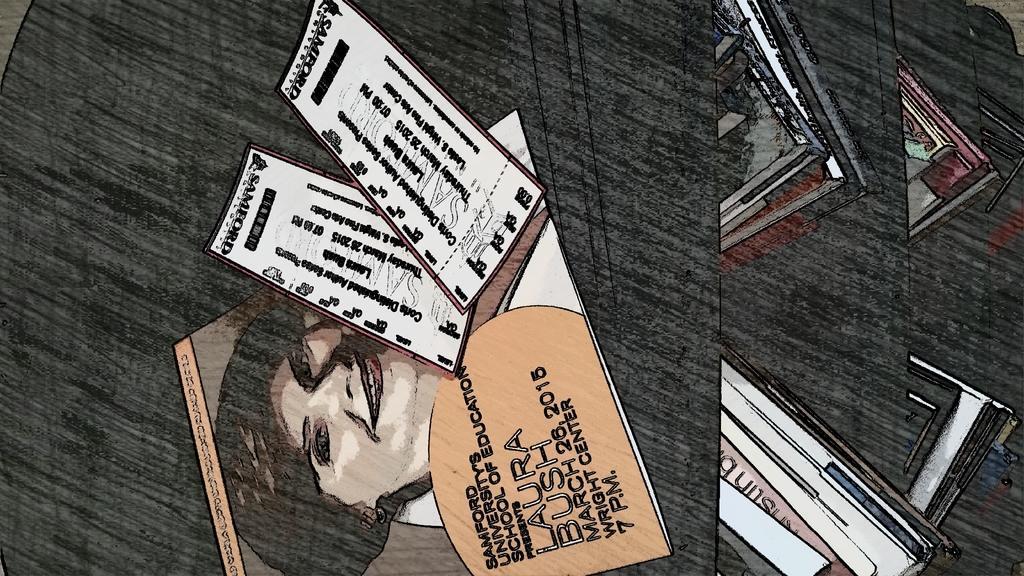Please provide a concise description of this image. In this image there is a painting. In the image, in the image, we can see a painting of a woman and some other paintings. In the background, we can also see black color. 